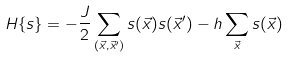<formula> <loc_0><loc_0><loc_500><loc_500>H \{ s \} = - { \frac { J } { 2 } } \sum _ { ( \vec { x } , { \vec { x } } ^ { \prime } ) } s ( { \vec { x } } ) s ( { \vec { x } } ^ { \prime } ) - h \sum _ { \vec { x } } s ( { \vec { x } } )</formula> 